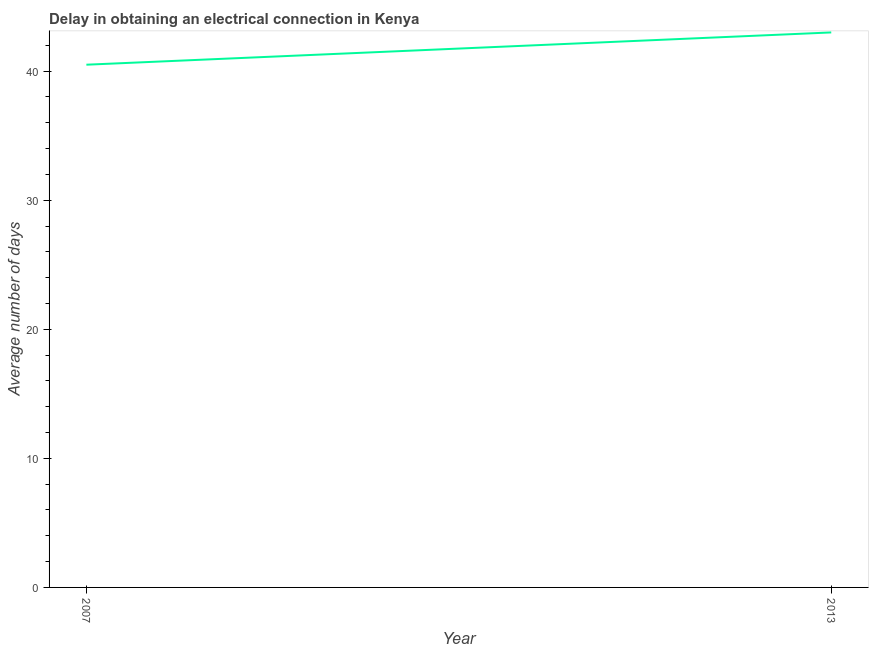What is the dalay in electrical connection in 2007?
Give a very brief answer. 40.5. Across all years, what is the minimum dalay in electrical connection?
Your response must be concise. 40.5. In which year was the dalay in electrical connection maximum?
Your answer should be compact. 2013. In which year was the dalay in electrical connection minimum?
Ensure brevity in your answer.  2007. What is the sum of the dalay in electrical connection?
Give a very brief answer. 83.5. What is the average dalay in electrical connection per year?
Offer a very short reply. 41.75. What is the median dalay in electrical connection?
Keep it short and to the point. 41.75. Do a majority of the years between 2013 and 2007 (inclusive) have dalay in electrical connection greater than 30 days?
Provide a short and direct response. No. What is the ratio of the dalay in electrical connection in 2007 to that in 2013?
Offer a very short reply. 0.94. In how many years, is the dalay in electrical connection greater than the average dalay in electrical connection taken over all years?
Offer a terse response. 1. Does the dalay in electrical connection monotonically increase over the years?
Your response must be concise. Yes. How many lines are there?
Keep it short and to the point. 1. Are the values on the major ticks of Y-axis written in scientific E-notation?
Ensure brevity in your answer.  No. What is the title of the graph?
Ensure brevity in your answer.  Delay in obtaining an electrical connection in Kenya. What is the label or title of the X-axis?
Give a very brief answer. Year. What is the label or title of the Y-axis?
Offer a terse response. Average number of days. What is the Average number of days in 2007?
Give a very brief answer. 40.5. What is the Average number of days in 2013?
Keep it short and to the point. 43. What is the ratio of the Average number of days in 2007 to that in 2013?
Provide a succinct answer. 0.94. 